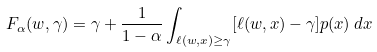Convert formula to latex. <formula><loc_0><loc_0><loc_500><loc_500>F _ { \alpha } ( w , \gamma ) = \gamma + { \frac { 1 } { 1 - \alpha } } \int _ { \ell ( w , x ) \geq \gamma } [ \ell ( w , x ) - \gamma ] p ( x ) \, d x</formula> 